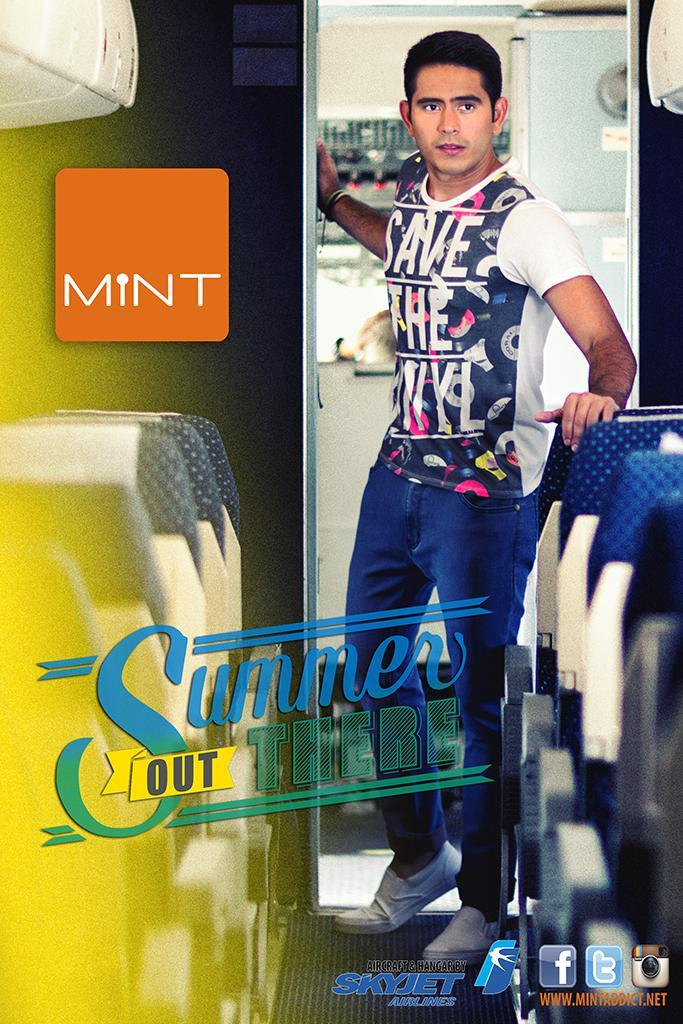<image>
Render a clear and concise summary of the photo. An ad has an orange box in the upper left corner that says Mint. 